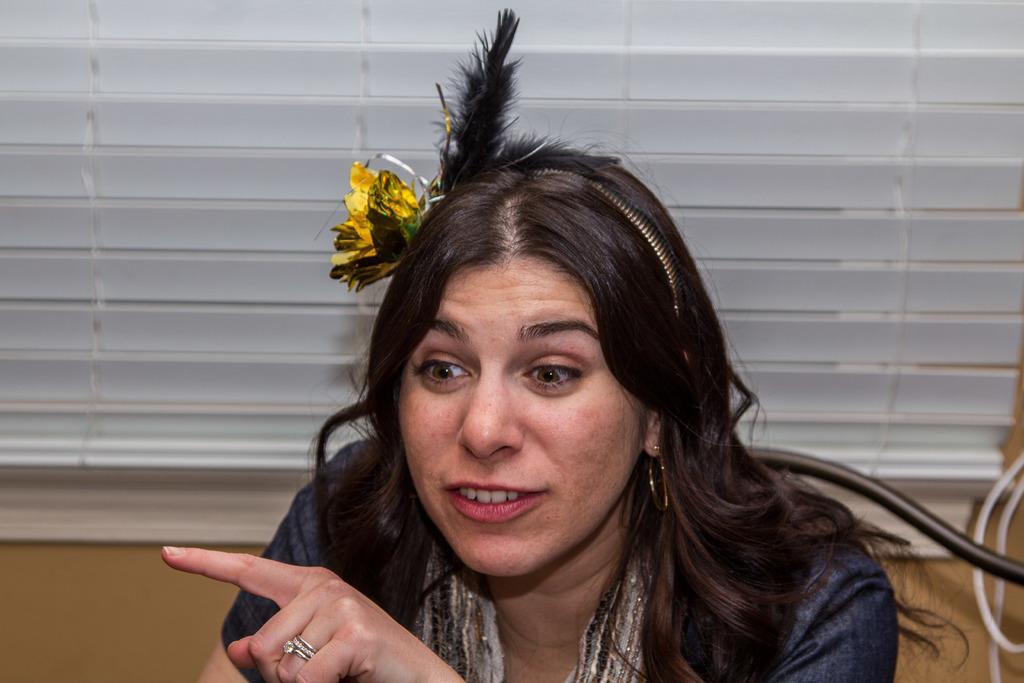Can you describe this image briefly? In this image we can see a woman. In the background there is a window blind, wall and objects. 